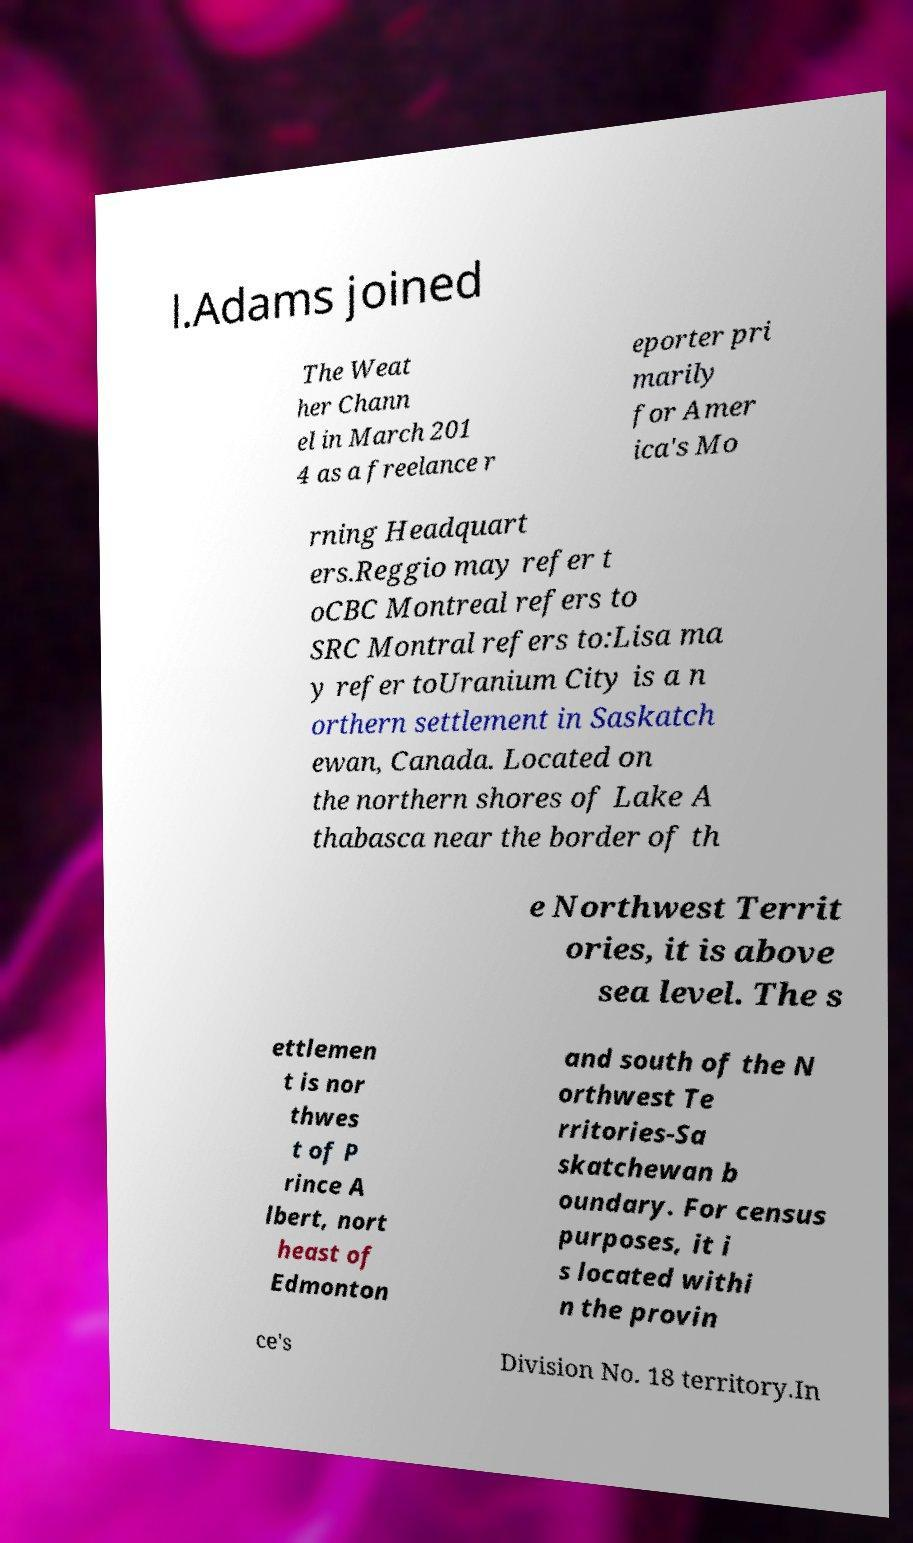Can you accurately transcribe the text from the provided image for me? l.Adams joined The Weat her Chann el in March 201 4 as a freelance r eporter pri marily for Amer ica's Mo rning Headquart ers.Reggio may refer t oCBC Montreal refers to SRC Montral refers to:Lisa ma y refer toUranium City is a n orthern settlement in Saskatch ewan, Canada. Located on the northern shores of Lake A thabasca near the border of th e Northwest Territ ories, it is above sea level. The s ettlemen t is nor thwes t of P rince A lbert, nort heast of Edmonton and south of the N orthwest Te rritories-Sa skatchewan b oundary. For census purposes, it i s located withi n the provin ce's Division No. 18 territory.In 